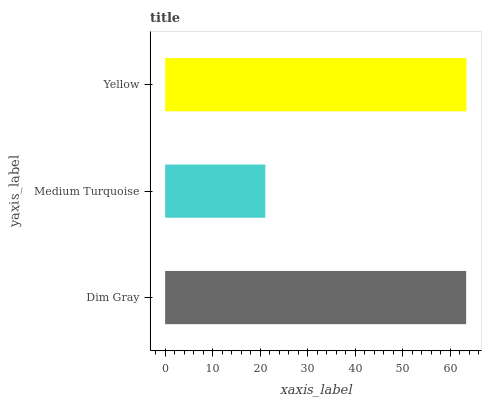Is Medium Turquoise the minimum?
Answer yes or no. Yes. Is Yellow the maximum?
Answer yes or no. Yes. Is Yellow the minimum?
Answer yes or no. No. Is Medium Turquoise the maximum?
Answer yes or no. No. Is Yellow greater than Medium Turquoise?
Answer yes or no. Yes. Is Medium Turquoise less than Yellow?
Answer yes or no. Yes. Is Medium Turquoise greater than Yellow?
Answer yes or no. No. Is Yellow less than Medium Turquoise?
Answer yes or no. No. Is Dim Gray the high median?
Answer yes or no. Yes. Is Dim Gray the low median?
Answer yes or no. Yes. Is Medium Turquoise the high median?
Answer yes or no. No. Is Medium Turquoise the low median?
Answer yes or no. No. 